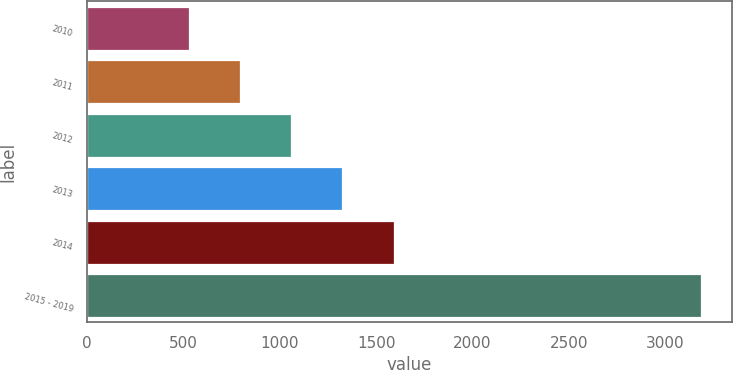<chart> <loc_0><loc_0><loc_500><loc_500><bar_chart><fcel>2010<fcel>2011<fcel>2012<fcel>2013<fcel>2014<fcel>2015 - 2019<nl><fcel>527<fcel>793.1<fcel>1059.2<fcel>1325.3<fcel>1591.4<fcel>3188<nl></chart> 